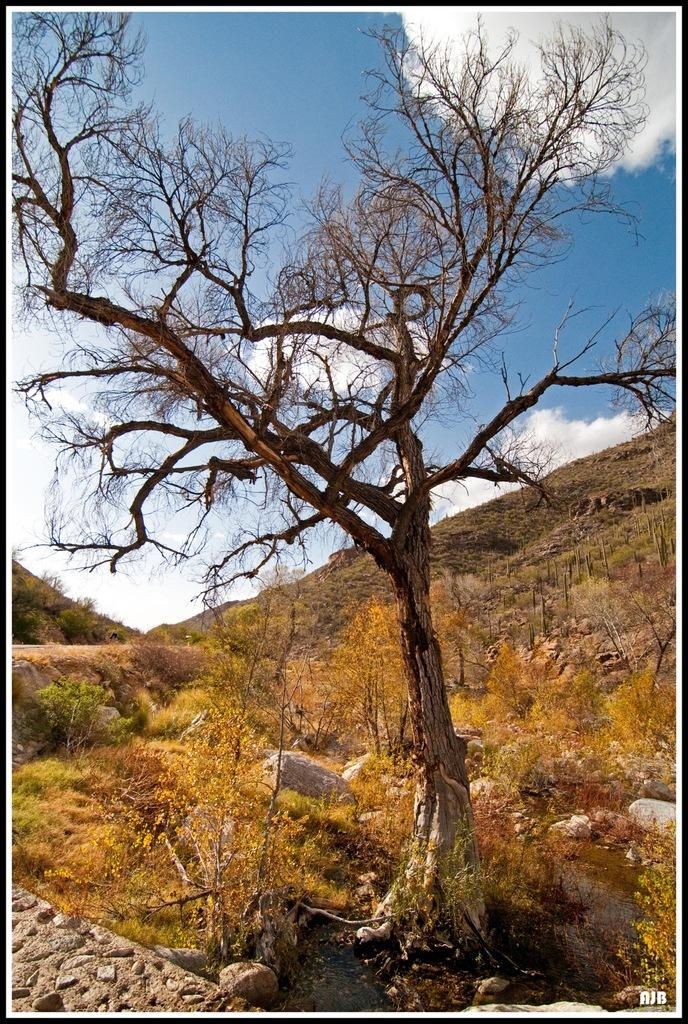What type of vegetation is present in the image? There is a tree and plants in the image. What other objects can be seen in the image? There are stones in the image. What can be seen in the background of the image? There are mountains and the sky in the background of the image. What is the condition of the sky in the image? The sky is visible in the background of the image, and there are clouds present. Can you tell me how many strangers are sitting on the roof in the image? There is no roof or stranger present in the image; it features a tree, plants, stones, mountains, and the sky. 